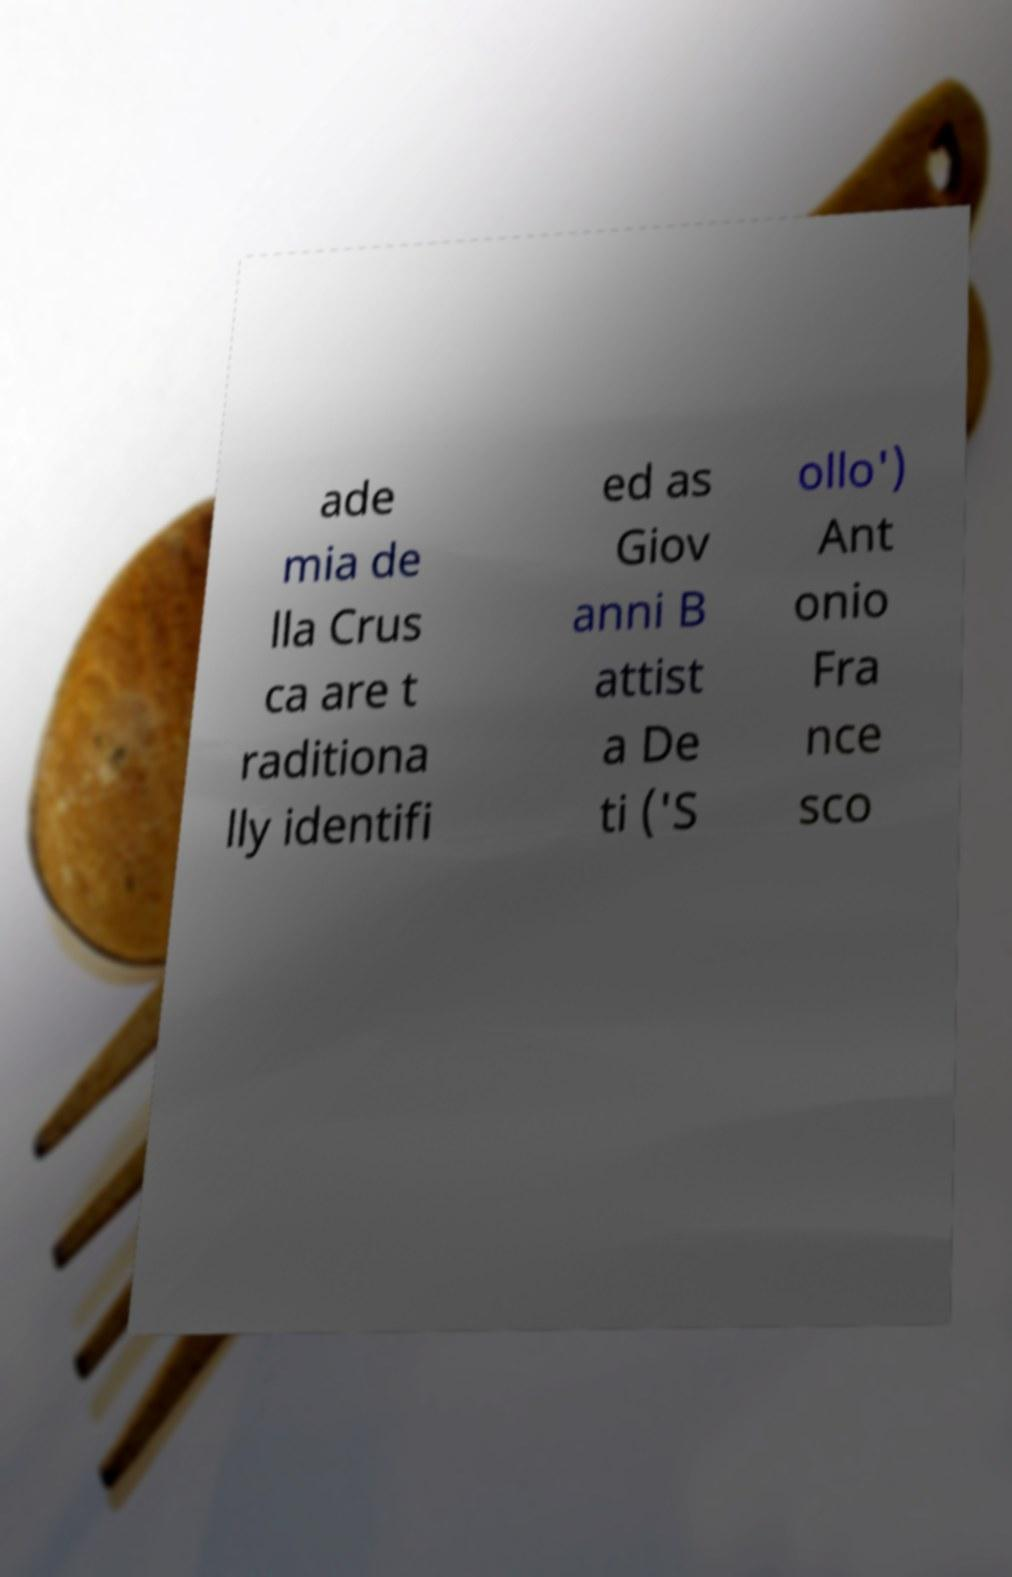Can you accurately transcribe the text from the provided image for me? ade mia de lla Crus ca are t raditiona lly identifi ed as Giov anni B attist a De ti ('S ollo') Ant onio Fra nce sco 